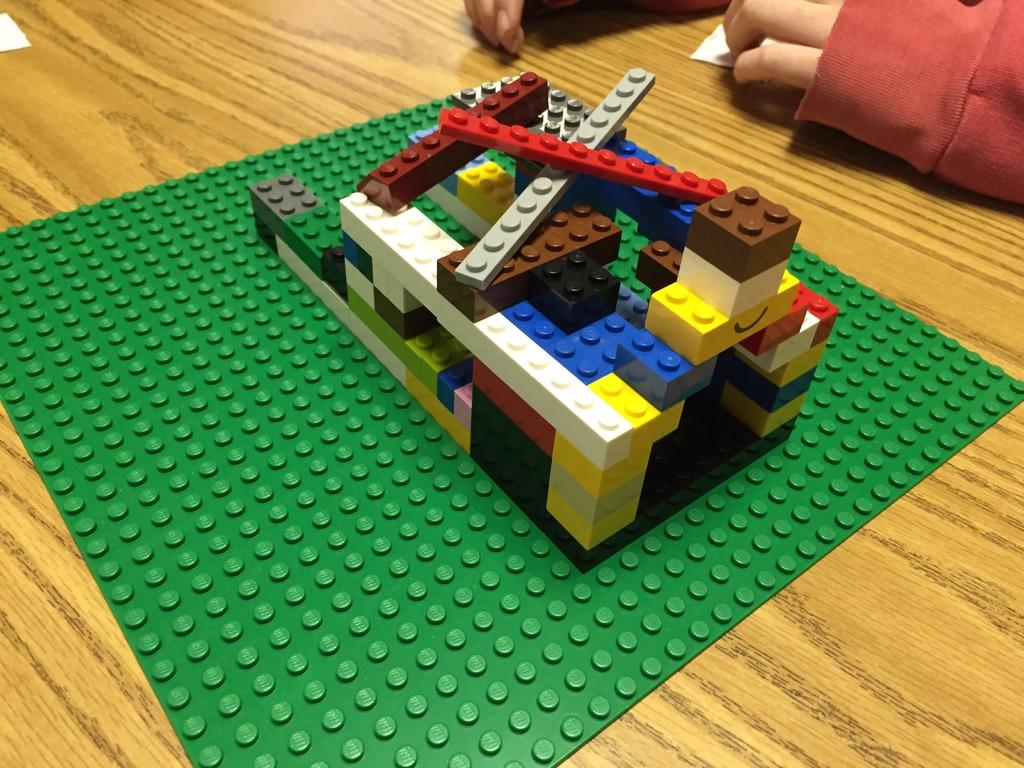What objects are on the table in the image? There are building blocks on the table. Can you describe the person behind the table? The person behind the table is not clearly visible, but their presence is indicated. What is the location of the paper on the table? The paper is on the table in the top left corner. What type of pot is being used by the person in the image? There is no pot visible in the image; the main objects on the table are building blocks. Can you tell me how many people are attending the church service in the image? There is no church or church service depicted in the image; it features building blocks on a table. 